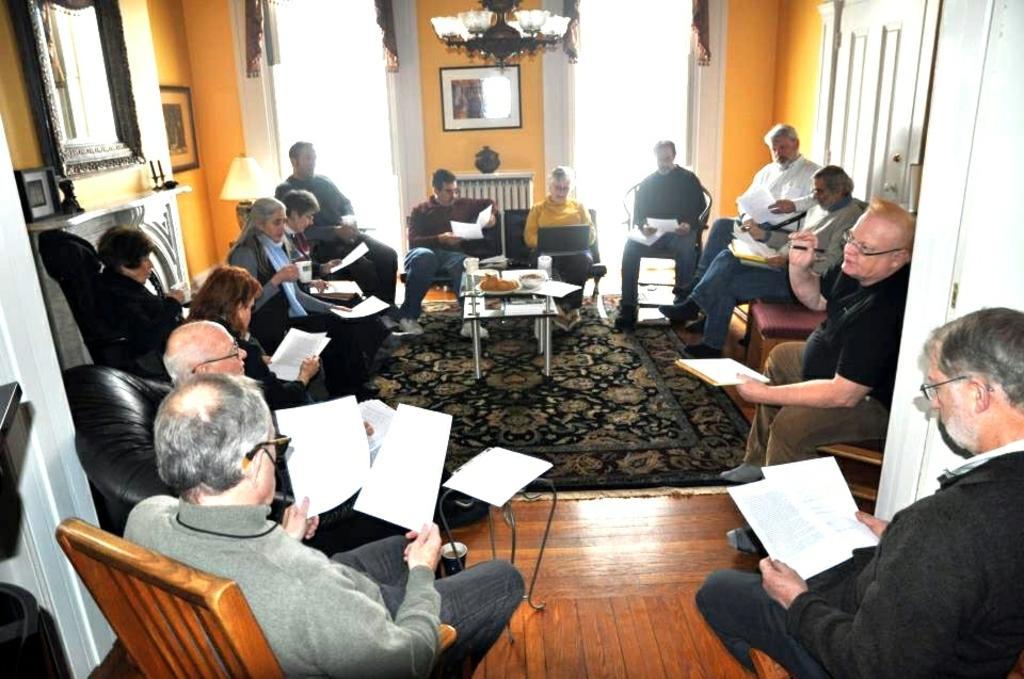How would you summarize this image in a sentence or two? The picture is taken in a closed room where number of people are sitting on the chairs and holding papers in their hands and in the middle one table is there on which some food, cups, glasses are kept and right corner there is one fire place and one mirror placed on the wall and photos placed on the wall, there are two big windows with curtains on it and in the middle one photo is on the wall and one chandelier is hanging from the roof. 